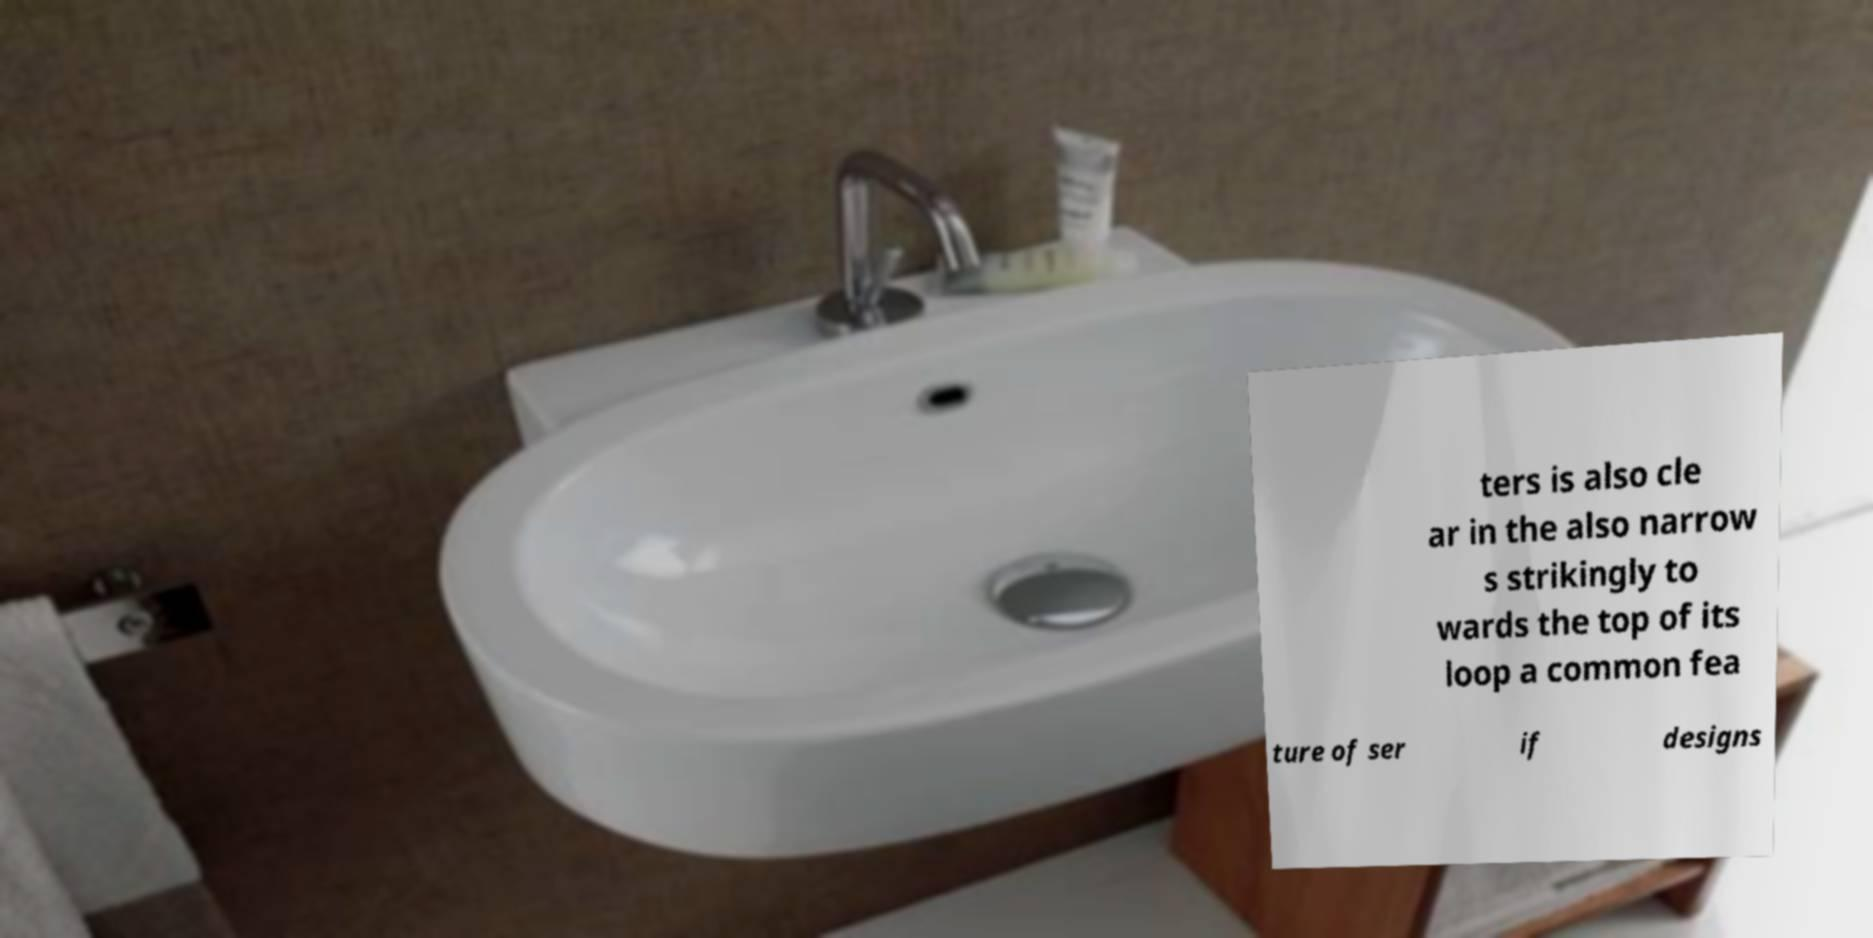For documentation purposes, I need the text within this image transcribed. Could you provide that? ters is also cle ar in the also narrow s strikingly to wards the top of its loop a common fea ture of ser if designs 